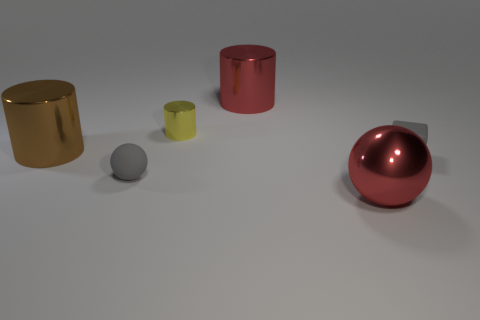The gray rubber ball has what size?
Your response must be concise. Small. What is the gray block made of?
Your response must be concise. Rubber. There is a brown object in front of the red shiny cylinder; does it have the same size as the small ball?
Ensure brevity in your answer.  No. What number of things are either small yellow cylinders or large purple metallic balls?
Ensure brevity in your answer.  1. What is the shape of the matte thing that is the same color as the block?
Offer a very short reply. Sphere. There is a object that is both right of the red cylinder and on the left side of the gray rubber block; what size is it?
Ensure brevity in your answer.  Large. How many yellow objects are there?
Provide a succinct answer. 1. What number of cylinders are either large red objects or brown objects?
Offer a terse response. 2. There is a tiny gray object that is to the left of the gray thing right of the shiny ball; how many large cylinders are on the left side of it?
Offer a very short reply. 1. What color is the shiny object that is the same size as the gray sphere?
Give a very brief answer. Yellow. 